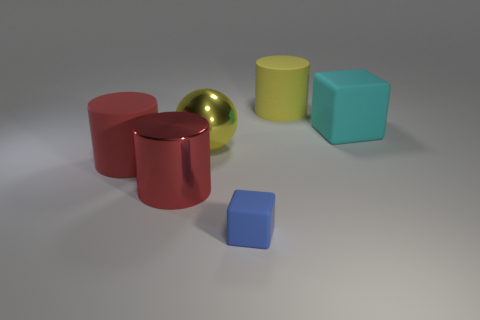Is the big cyan object the same shape as the small thing?
Make the answer very short. Yes. There is a thing to the right of the big rubber cylinder to the right of the red shiny thing; what is its material?
Provide a succinct answer. Rubber. What shape is the blue object?
Your answer should be compact. Cube. How many objects are either balls in front of the big cube or tiny gray matte objects?
Provide a short and direct response. 1. What number of other objects are there of the same color as the large shiny ball?
Provide a succinct answer. 1. There is a metallic sphere; does it have the same color as the cylinder behind the cyan block?
Your answer should be very brief. Yes. There is a big object that is the same shape as the tiny thing; what color is it?
Your answer should be very brief. Cyan. Does the yellow cylinder have the same material as the large yellow object left of the yellow matte thing?
Your answer should be very brief. No. What color is the large block?
Keep it short and to the point. Cyan. What color is the big cylinder that is to the right of the metallic thing in front of the big yellow object that is in front of the big cyan thing?
Offer a very short reply. Yellow. 